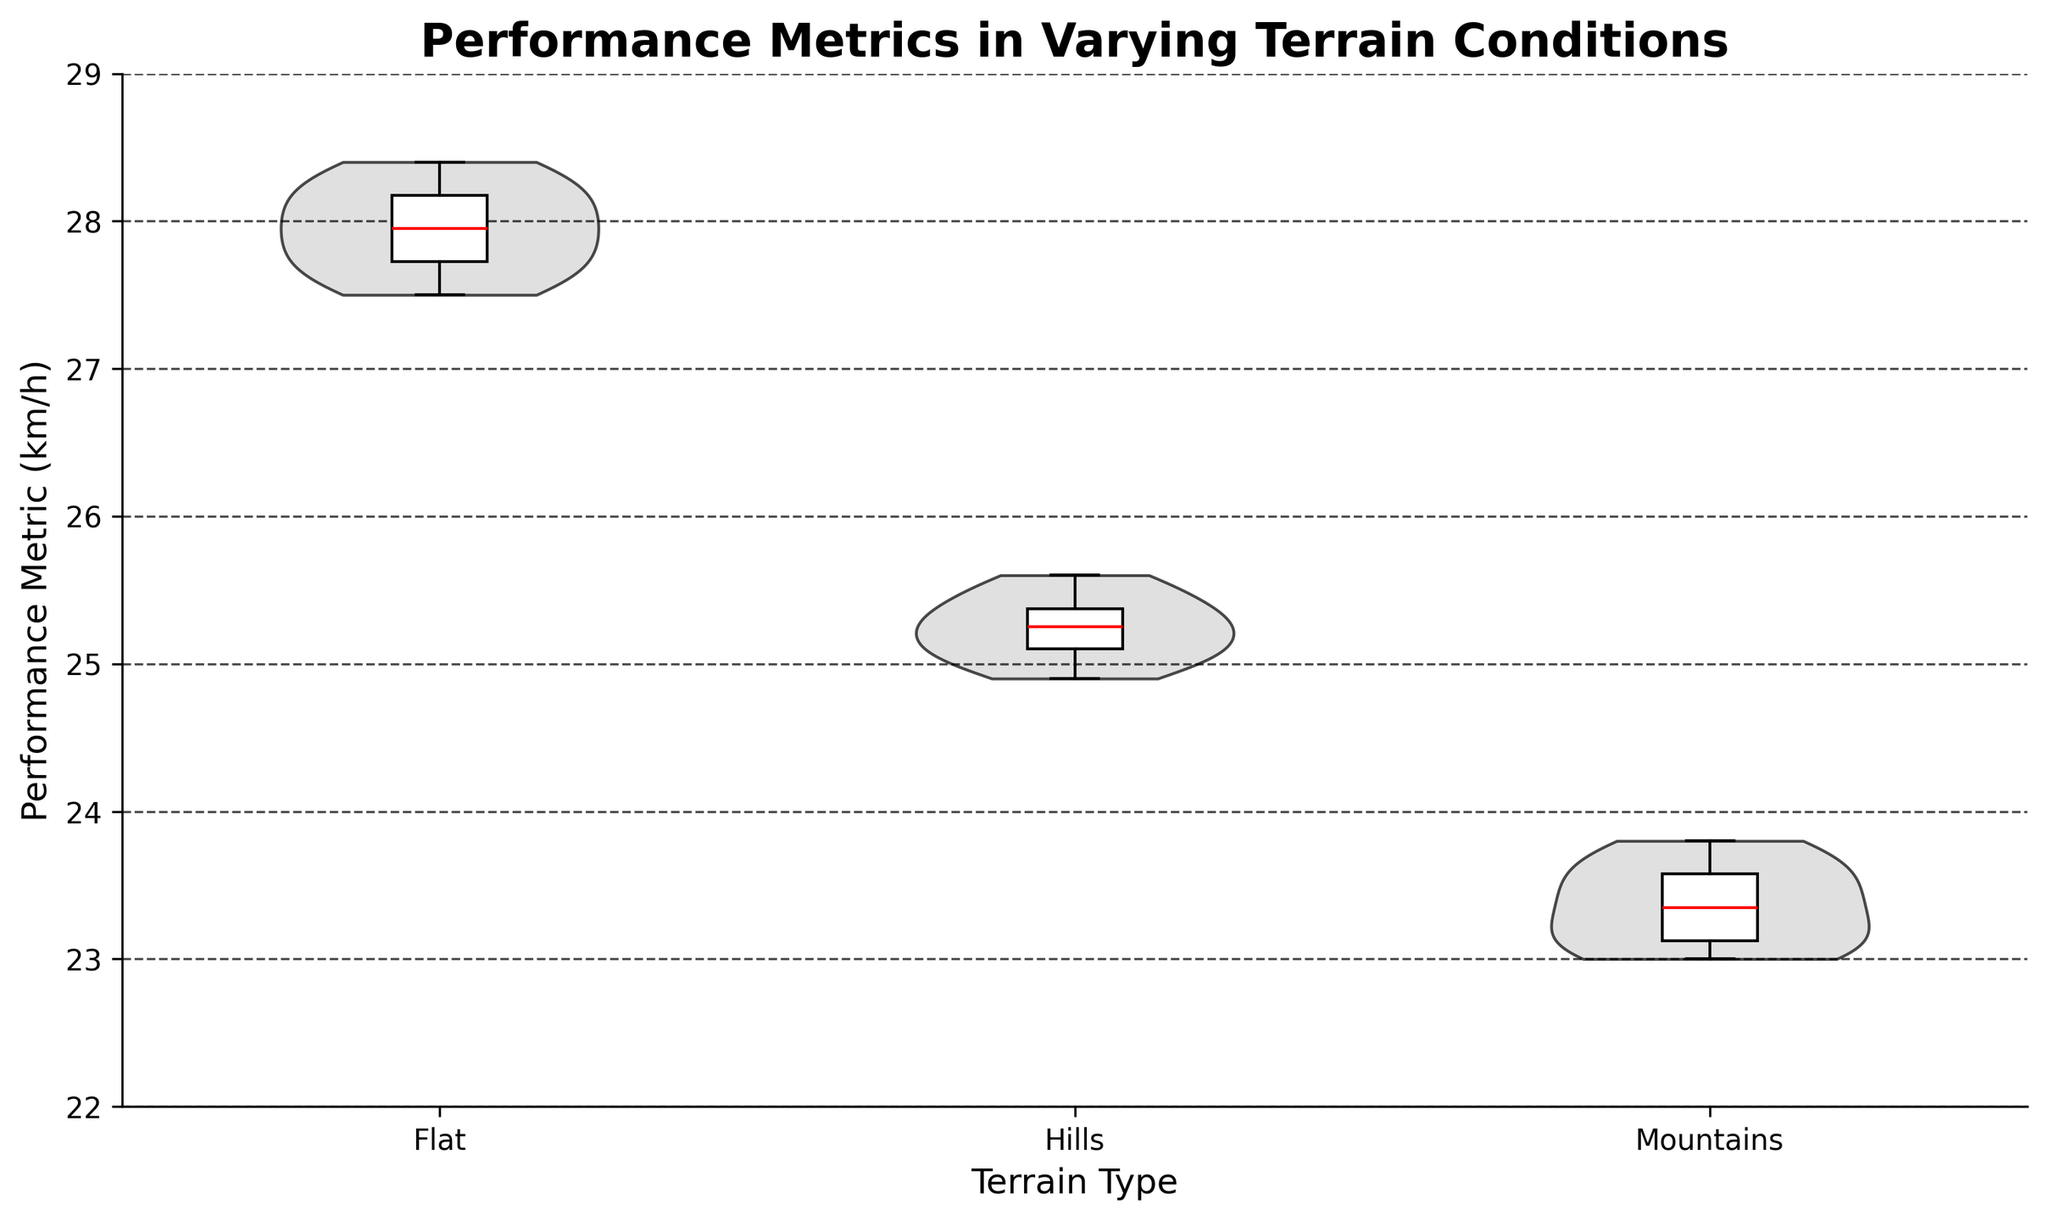What is the title of the figure? The title is typically displayed at the top of the figure and it provides an overview of the content.
Answer: Performance Metrics in Varying Terrain Conditions What are the labels on the x-axis? The x-axis labels indicate the categories or groups being compared. In this figure, they correspond to the terrain types.
Answer: Flat, Hills, Mountains Which terrain type shows the highest median performance metric? The boxplot overlay on the violin chart displays the median value with a red line. The terrain with the highest median red line represents the highest median performance metric.
Answer: Flat What is the range of the y-axis? The range of an axis can be determined by looking at the lowest and highest tick marks on the axis. In this figure, the y-axis spans from 22 to 29.
Answer: 22 to 29 Which terrain has the smallest interquartile range (IQR)? The interquartile range (IQR) is the box in a boxplot. The terrain with the smallest box has the smallest IQR. You can determine this by comparing the height of the boxes.
Answer: Flat Which terrain type has the widest distribution of performance metrics? The width of the violin plot provides a sense of the distribution. The wider the plot, the greater the distribution of values.
Answer: Mountains How do the performance metrics in 'Flat' terrain compare to those in 'Hills'? This question requires comparing the central tendencies (medians) and spread (distributions) of the 'Flat' and 'Hills' terrains. The median for 'Flat' is higher, and its distribution is slightly narrower.
Answer: Flat has a higher median and narrower distribution Which terrain has the lowest performance metric value and what is it approximately? This can be observed from the low end of the violin plots or by looking at the whiskers of the boxplots showing the minimum values. The lowest performance metric is in the 'Mountains' terrain.
Answer: Mountains, approximately 23.0 What's the performance metric range for the 'Hills' terrain? The range can be determined by looking at the whiskers of the boxplot for 'Hills' terrain, which shows the minimum and maximum values.
Answer: Approximately 24.9 to 25.6 How does the performance metric in 'Mountains' differ from 'Flat'? This involves comparing both the central tendencies and the spread. The median for 'Mountains' is lower, and the distribution is wider. This indicates more variability and generally lower performance in mountainous terrain.
Answer: Mountains have a lower median and wider distribution 